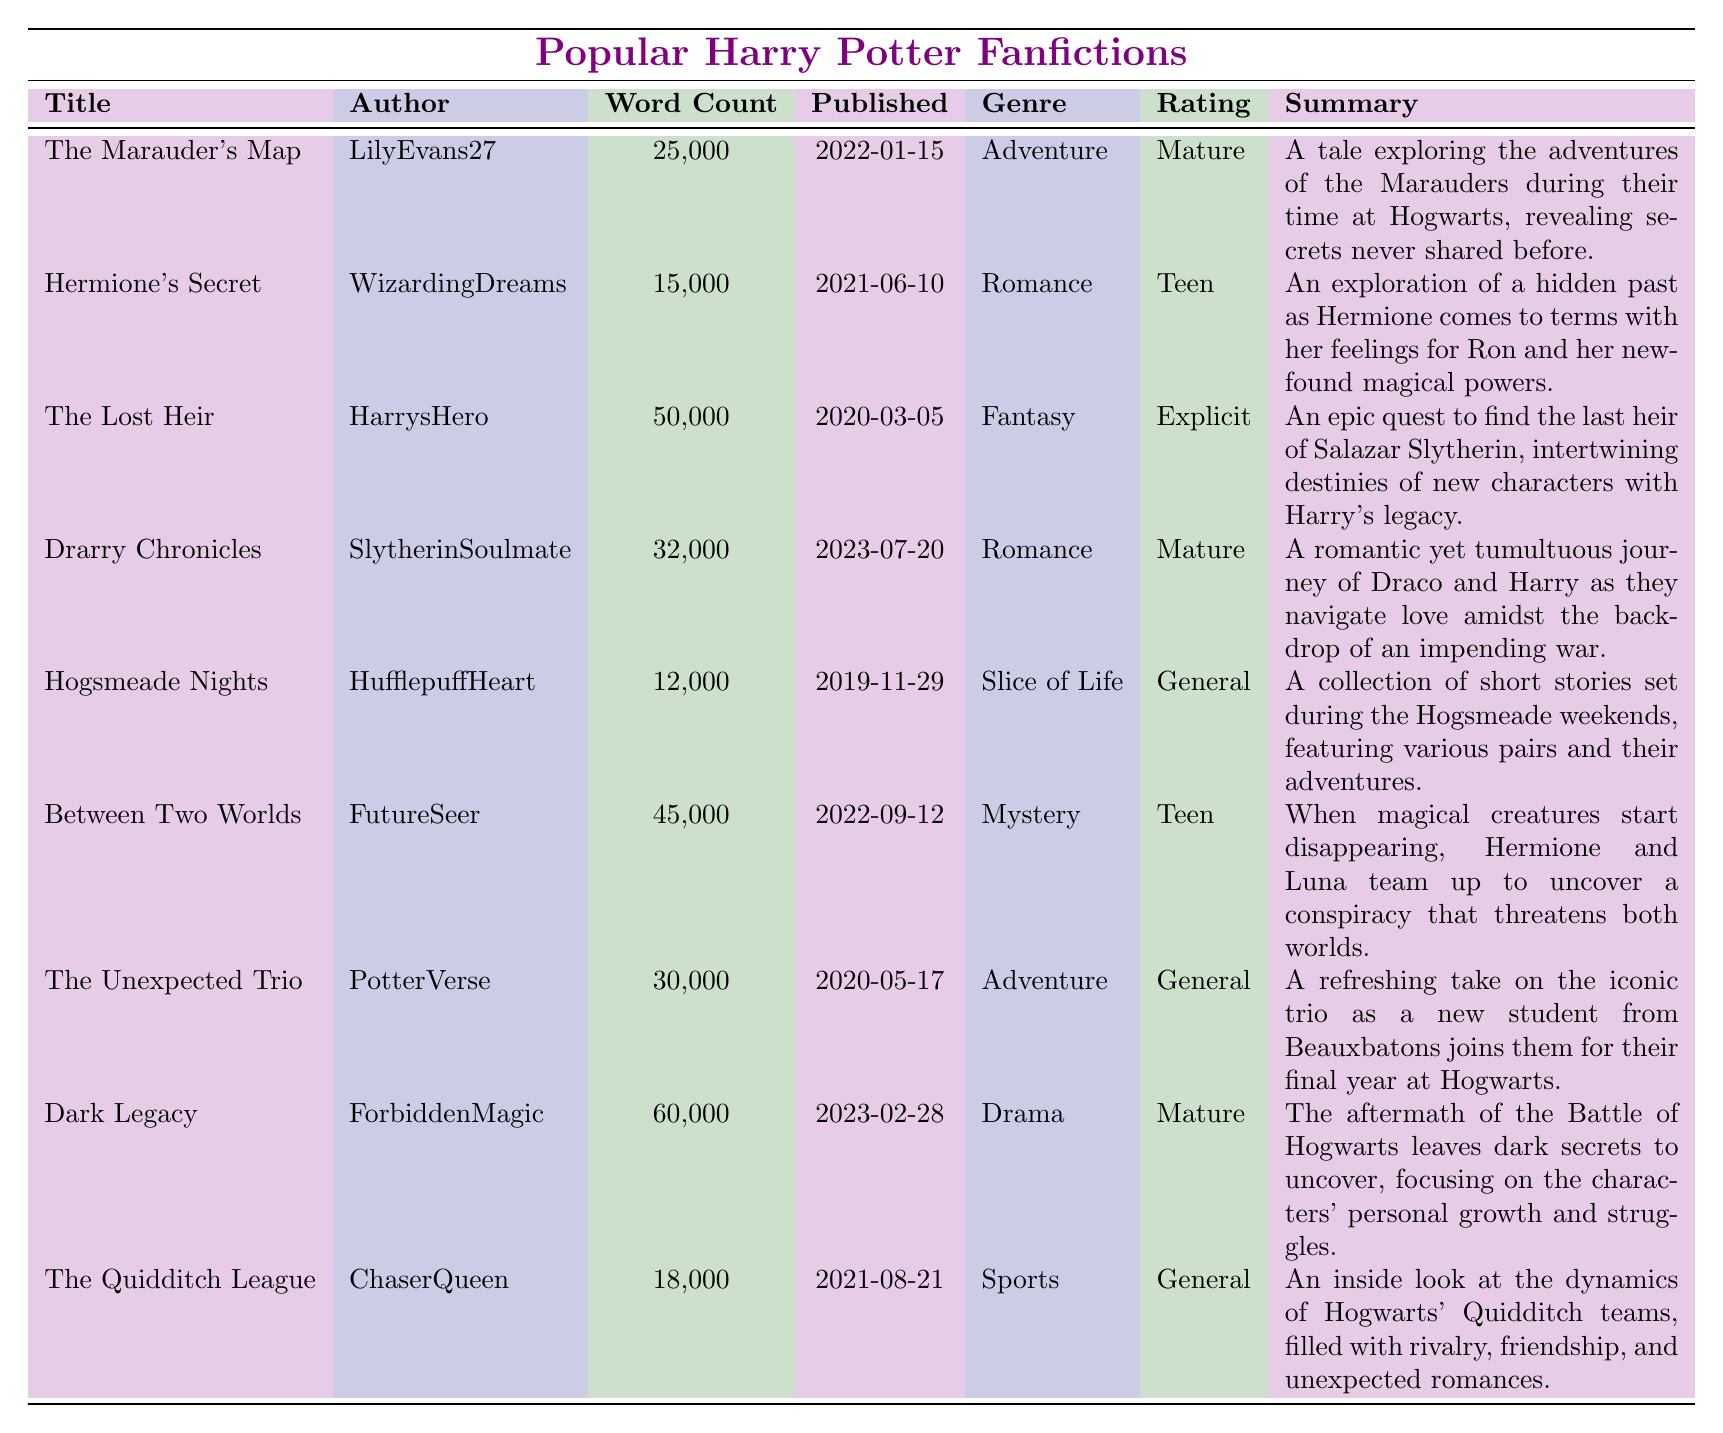What is the highest word count among the fanfictions? To find the highest word count, we look at the Word Count column and find that "Dark Legacy" has the highest count of 60,000 words.
Answer: 60,000 Who is the author of "The Lost Heir"? The table lists "HarrysHero" as the author of "The Lost Heir".
Answer: HarrysHero How many stories are categorized under the genre 'Romance'? By checking the Genre column, we see that there are two stories labeled as Romance: "Hermione's Secret" and "Drarry Chronicles".
Answer: 2 What is the average word count of all the fanfictions listed? To calculate the average, first sum the word counts: 25,000 + 15,000 + 50,000 + 32,000 + 12,000 + 45,000 + 30,000 + 60,000 + 18,000 =  247,000. There are 9 stories, so the average is 247,000 / 9 ≈ 27,444.
Answer: 27,444 Is "Hogsmeade Nights" rated as 'Mature'? Checking the Rating column for "Hogsmeade Nights" shows that it is rated as 'General', not 'Mature'.
Answer: No Which story was published most recently? The most recent publication date listed is "2023-07-20" for "Drarry Chronicles".
Answer: Drarry Chronicles What is the total word count of the fanfictions rated 'Teen'? The fanfictions rated 'Teen' are "Hermione's Secret" (15,000) and "Between Two Worlds" (45,000). Adding these yields a total word count of 15,000 + 45,000 = 60,000.
Answer: 60,000 Which fanfiction has the longest summary? By reviewing the Summary column, "Dark Legacy" has the longest summary which contains more detailed information compared to the others.
Answer: Dark Legacy How many fanfictions are categorized as 'Adventure'? "The Marauder's Map" and "The Unexpected Trio" are both categorized as Adventure, resulting in a total of 2 fanfictions.
Answer: 2 Are there any explicit-rated fanfictions, and if so, how many? The table shows that "The Lost Heir" is rated as 'Explicit'. Therefore, there is 1 explicit-rated fanfiction.
Answer: 1 